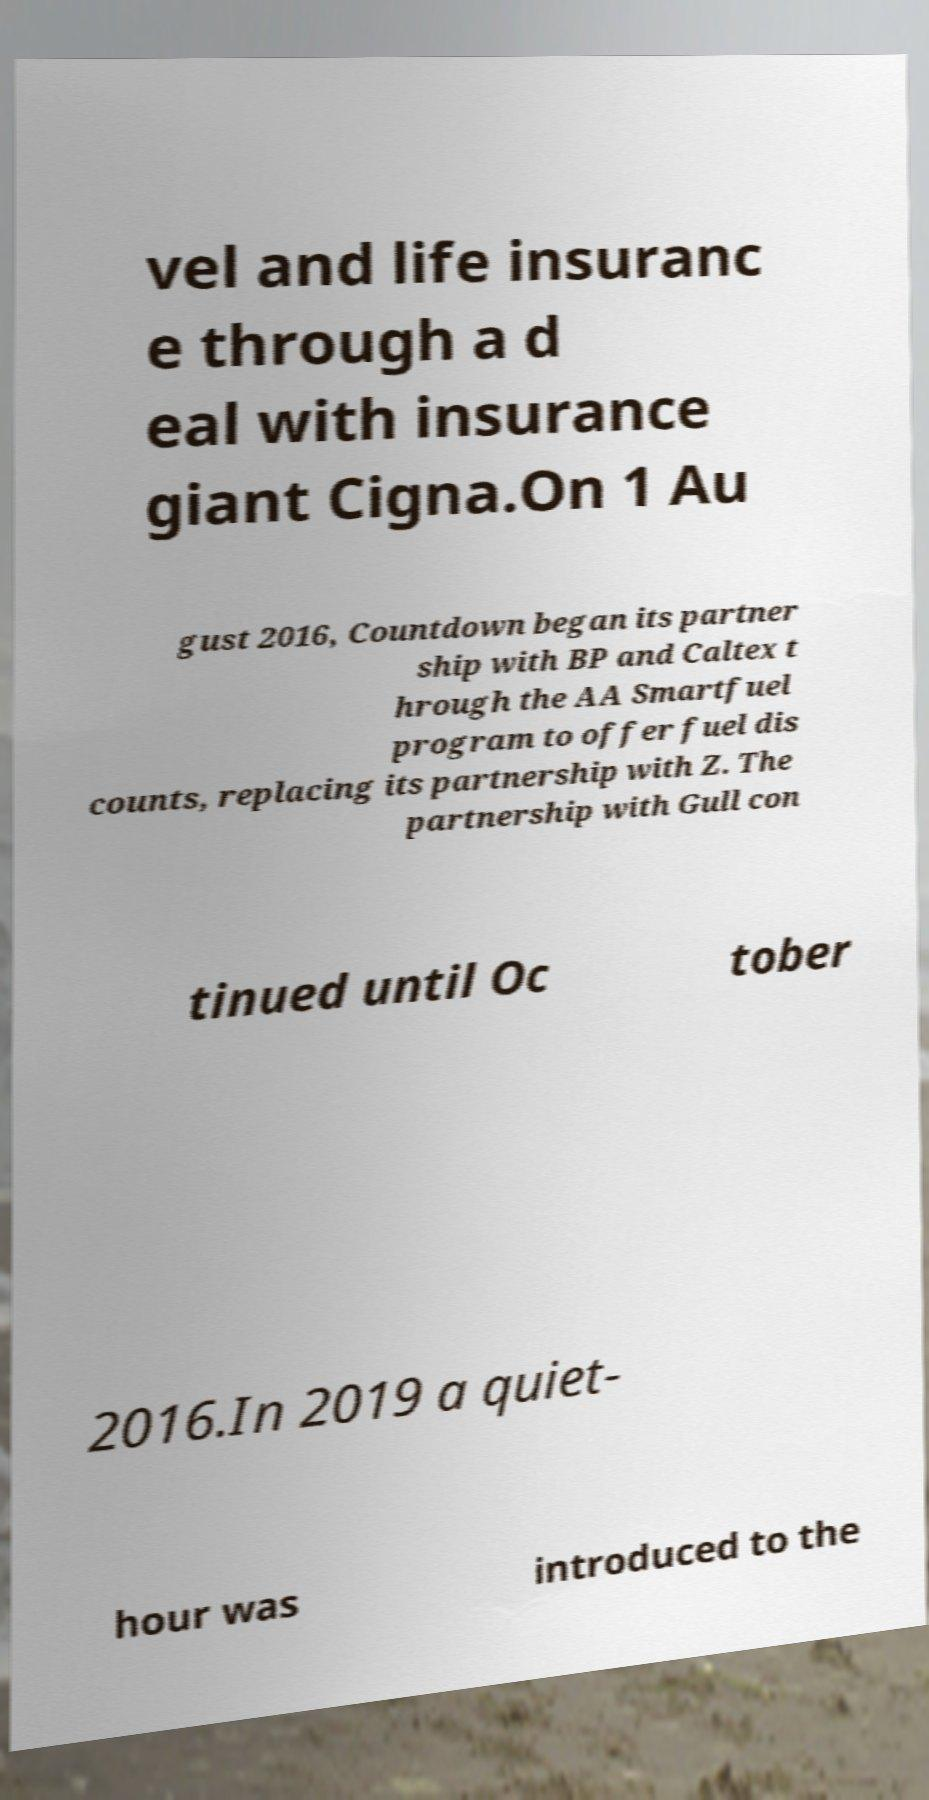Please identify and transcribe the text found in this image. vel and life insuranc e through a d eal with insurance giant Cigna.On 1 Au gust 2016, Countdown began its partner ship with BP and Caltex t hrough the AA Smartfuel program to offer fuel dis counts, replacing its partnership with Z. The partnership with Gull con tinued until Oc tober 2016.In 2019 a quiet- hour was introduced to the 